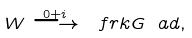<formula> <loc_0><loc_0><loc_500><loc_500>W \stackrel { 0 + i } { \longrightarrow } \ f r k G _ { \ } a d ,</formula> 